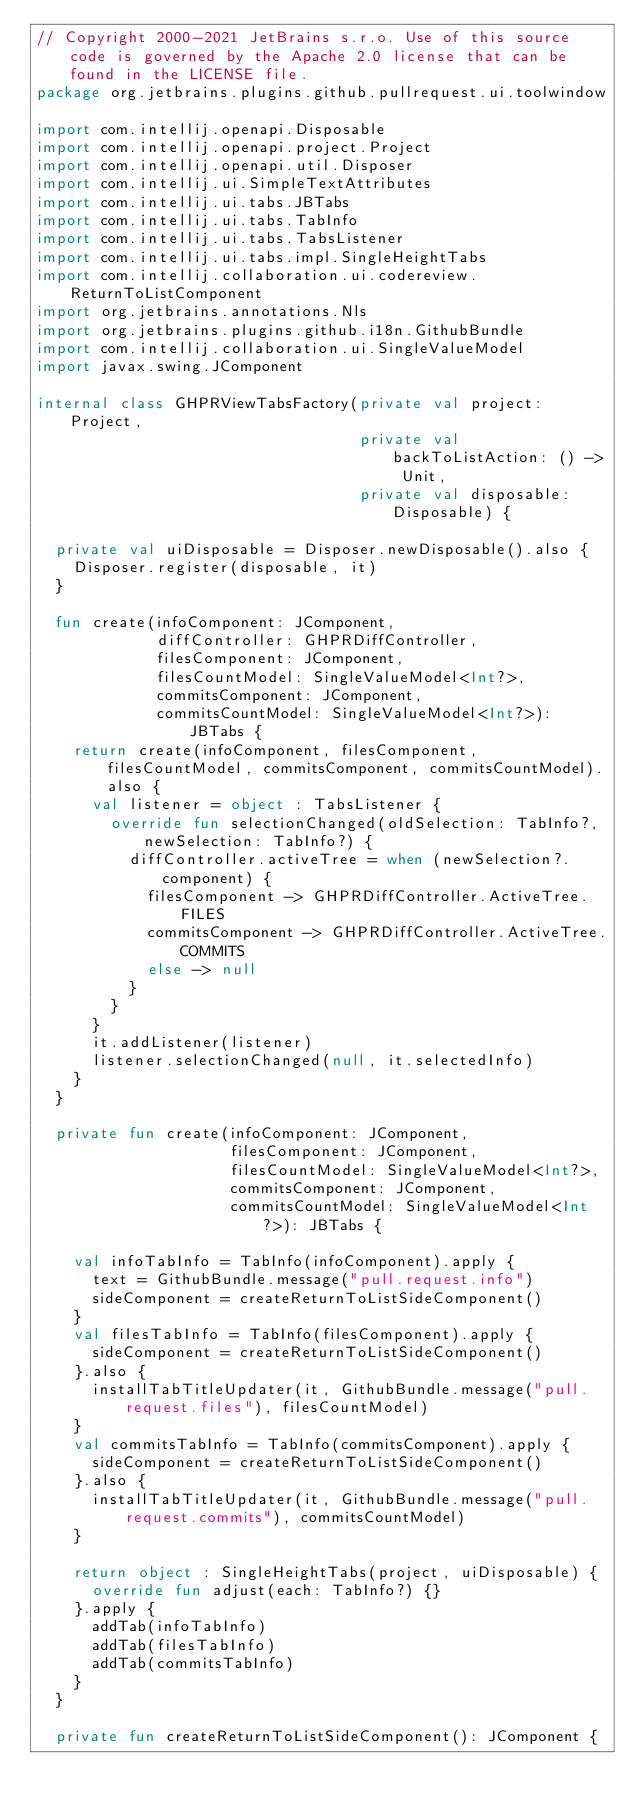Convert code to text. <code><loc_0><loc_0><loc_500><loc_500><_Kotlin_>// Copyright 2000-2021 JetBrains s.r.o. Use of this source code is governed by the Apache 2.0 license that can be found in the LICENSE file.
package org.jetbrains.plugins.github.pullrequest.ui.toolwindow

import com.intellij.openapi.Disposable
import com.intellij.openapi.project.Project
import com.intellij.openapi.util.Disposer
import com.intellij.ui.SimpleTextAttributes
import com.intellij.ui.tabs.JBTabs
import com.intellij.ui.tabs.TabInfo
import com.intellij.ui.tabs.TabsListener
import com.intellij.ui.tabs.impl.SingleHeightTabs
import com.intellij.collaboration.ui.codereview.ReturnToListComponent
import org.jetbrains.annotations.Nls
import org.jetbrains.plugins.github.i18n.GithubBundle
import com.intellij.collaboration.ui.SingleValueModel
import javax.swing.JComponent

internal class GHPRViewTabsFactory(private val project: Project,
                                   private val backToListAction: () -> Unit,
                                   private val disposable: Disposable) {

  private val uiDisposable = Disposer.newDisposable().also {
    Disposer.register(disposable, it)
  }

  fun create(infoComponent: JComponent,
             diffController: GHPRDiffController,
             filesComponent: JComponent,
             filesCountModel: SingleValueModel<Int?>,
             commitsComponent: JComponent,
             commitsCountModel: SingleValueModel<Int?>): JBTabs {
    return create(infoComponent, filesComponent, filesCountModel, commitsComponent, commitsCountModel).also {
      val listener = object : TabsListener {
        override fun selectionChanged(oldSelection: TabInfo?, newSelection: TabInfo?) {
          diffController.activeTree = when (newSelection?.component) {
            filesComponent -> GHPRDiffController.ActiveTree.FILES
            commitsComponent -> GHPRDiffController.ActiveTree.COMMITS
            else -> null
          }
        }
      }
      it.addListener(listener)
      listener.selectionChanged(null, it.selectedInfo)
    }
  }

  private fun create(infoComponent: JComponent,
                     filesComponent: JComponent,
                     filesCountModel: SingleValueModel<Int?>,
                     commitsComponent: JComponent,
                     commitsCountModel: SingleValueModel<Int?>): JBTabs {

    val infoTabInfo = TabInfo(infoComponent).apply {
      text = GithubBundle.message("pull.request.info")
      sideComponent = createReturnToListSideComponent()
    }
    val filesTabInfo = TabInfo(filesComponent).apply {
      sideComponent = createReturnToListSideComponent()
    }.also {
      installTabTitleUpdater(it, GithubBundle.message("pull.request.files"), filesCountModel)
    }
    val commitsTabInfo = TabInfo(commitsComponent).apply {
      sideComponent = createReturnToListSideComponent()
    }.also {
      installTabTitleUpdater(it, GithubBundle.message("pull.request.commits"), commitsCountModel)
    }

    return object : SingleHeightTabs(project, uiDisposable) {
      override fun adjust(each: TabInfo?) {}
    }.apply {
      addTab(infoTabInfo)
      addTab(filesTabInfo)
      addTab(commitsTabInfo)
    }
  }

  private fun createReturnToListSideComponent(): JComponent {</code> 